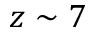Convert formula to latex. <formula><loc_0><loc_0><loc_500><loc_500>z \sim 7</formula> 